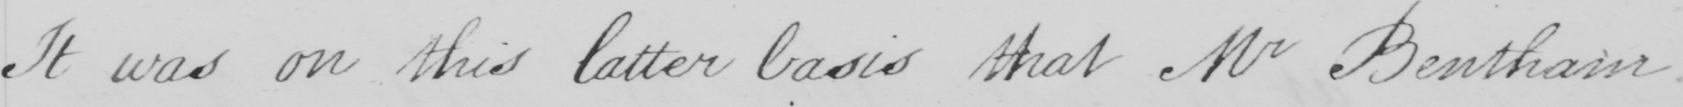What text is written in this handwritten line? It was on this latter basis that Mr Bentham 